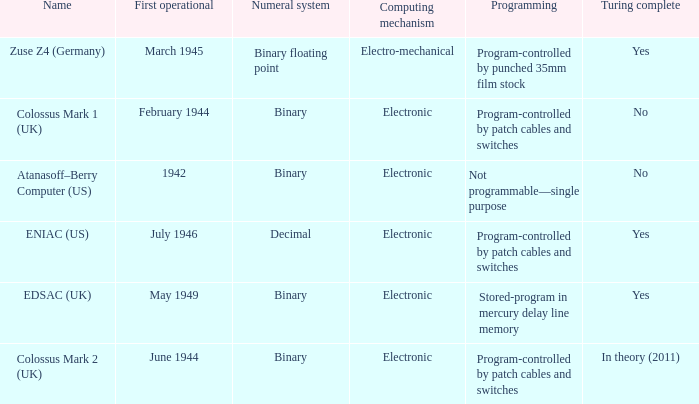What's the computing mechanbeingm with first operational being february 1944 Electronic. 